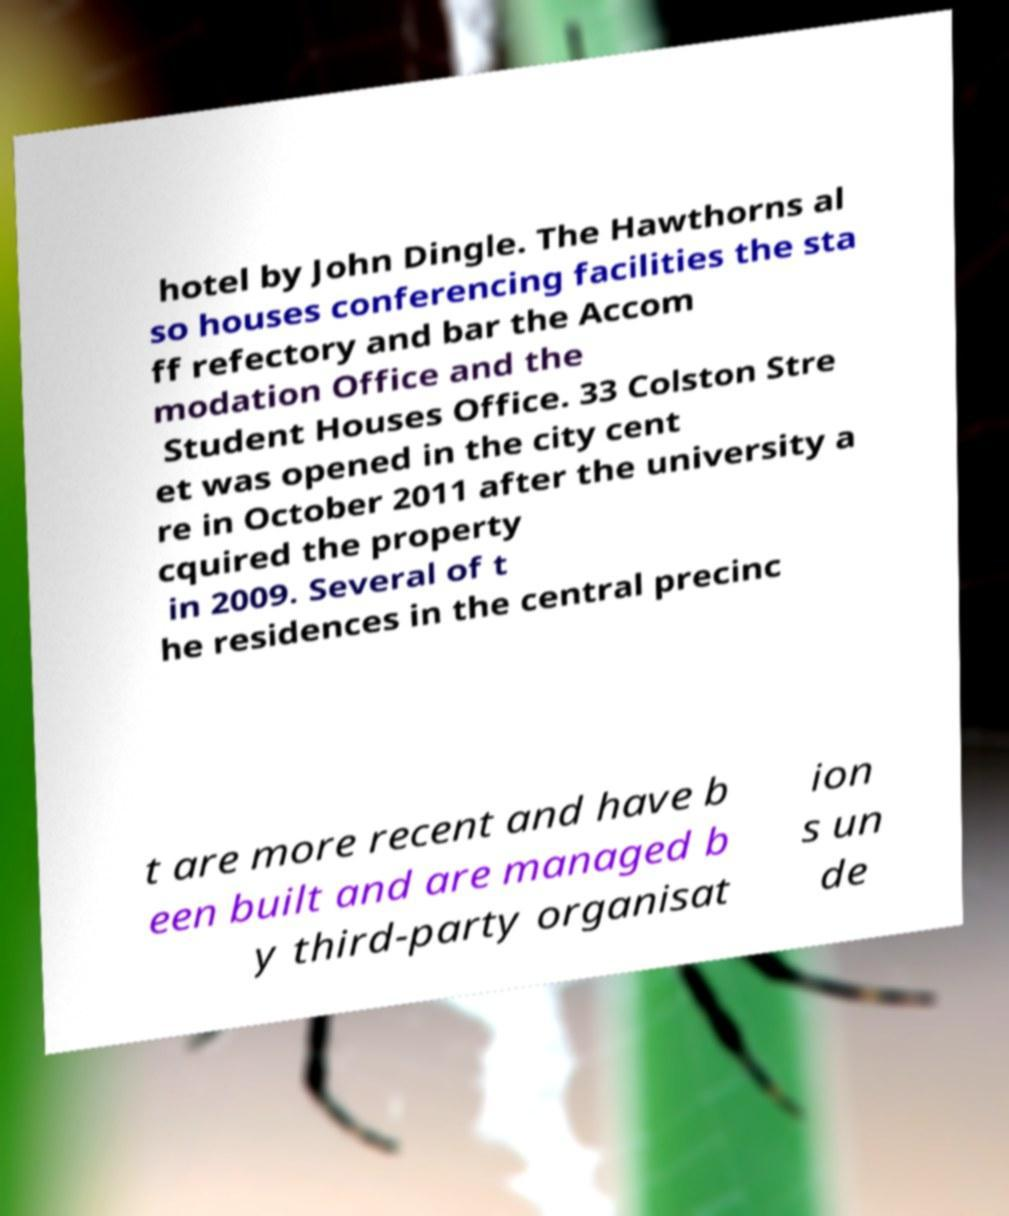Could you assist in decoding the text presented in this image and type it out clearly? hotel by John Dingle. The Hawthorns al so houses conferencing facilities the sta ff refectory and bar the Accom modation Office and the Student Houses Office. 33 Colston Stre et was opened in the city cent re in October 2011 after the university a cquired the property in 2009. Several of t he residences in the central precinc t are more recent and have b een built and are managed b y third-party organisat ion s un de 